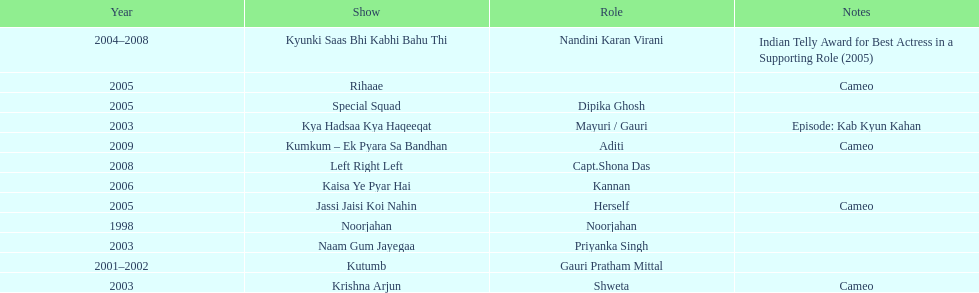How many total television shows has gauri starred in? 12. I'm looking to parse the entire table for insights. Could you assist me with that? {'header': ['Year', 'Show', 'Role', 'Notes'], 'rows': [['2004–2008', 'Kyunki Saas Bhi Kabhi Bahu Thi', 'Nandini Karan Virani', 'Indian Telly Award for Best Actress in a Supporting Role (2005)'], ['2005', 'Rihaae', '', 'Cameo'], ['2005', 'Special Squad', 'Dipika Ghosh', ''], ['2003', 'Kya Hadsaa Kya Haqeeqat', 'Mayuri / Gauri', 'Episode: Kab Kyun Kahan'], ['2009', 'Kumkum – Ek Pyara Sa Bandhan', 'Aditi', 'Cameo'], ['2008', 'Left Right Left', 'Capt.Shona Das', ''], ['2006', 'Kaisa Ye Pyar Hai', 'Kannan', ''], ['2005', 'Jassi Jaisi Koi Nahin', 'Herself', 'Cameo'], ['1998', 'Noorjahan', 'Noorjahan', ''], ['2003', 'Naam Gum Jayegaa', 'Priyanka Singh', ''], ['2001–2002', 'Kutumb', 'Gauri Pratham Mittal', ''], ['2003', 'Krishna Arjun', 'Shweta', 'Cameo']]} 